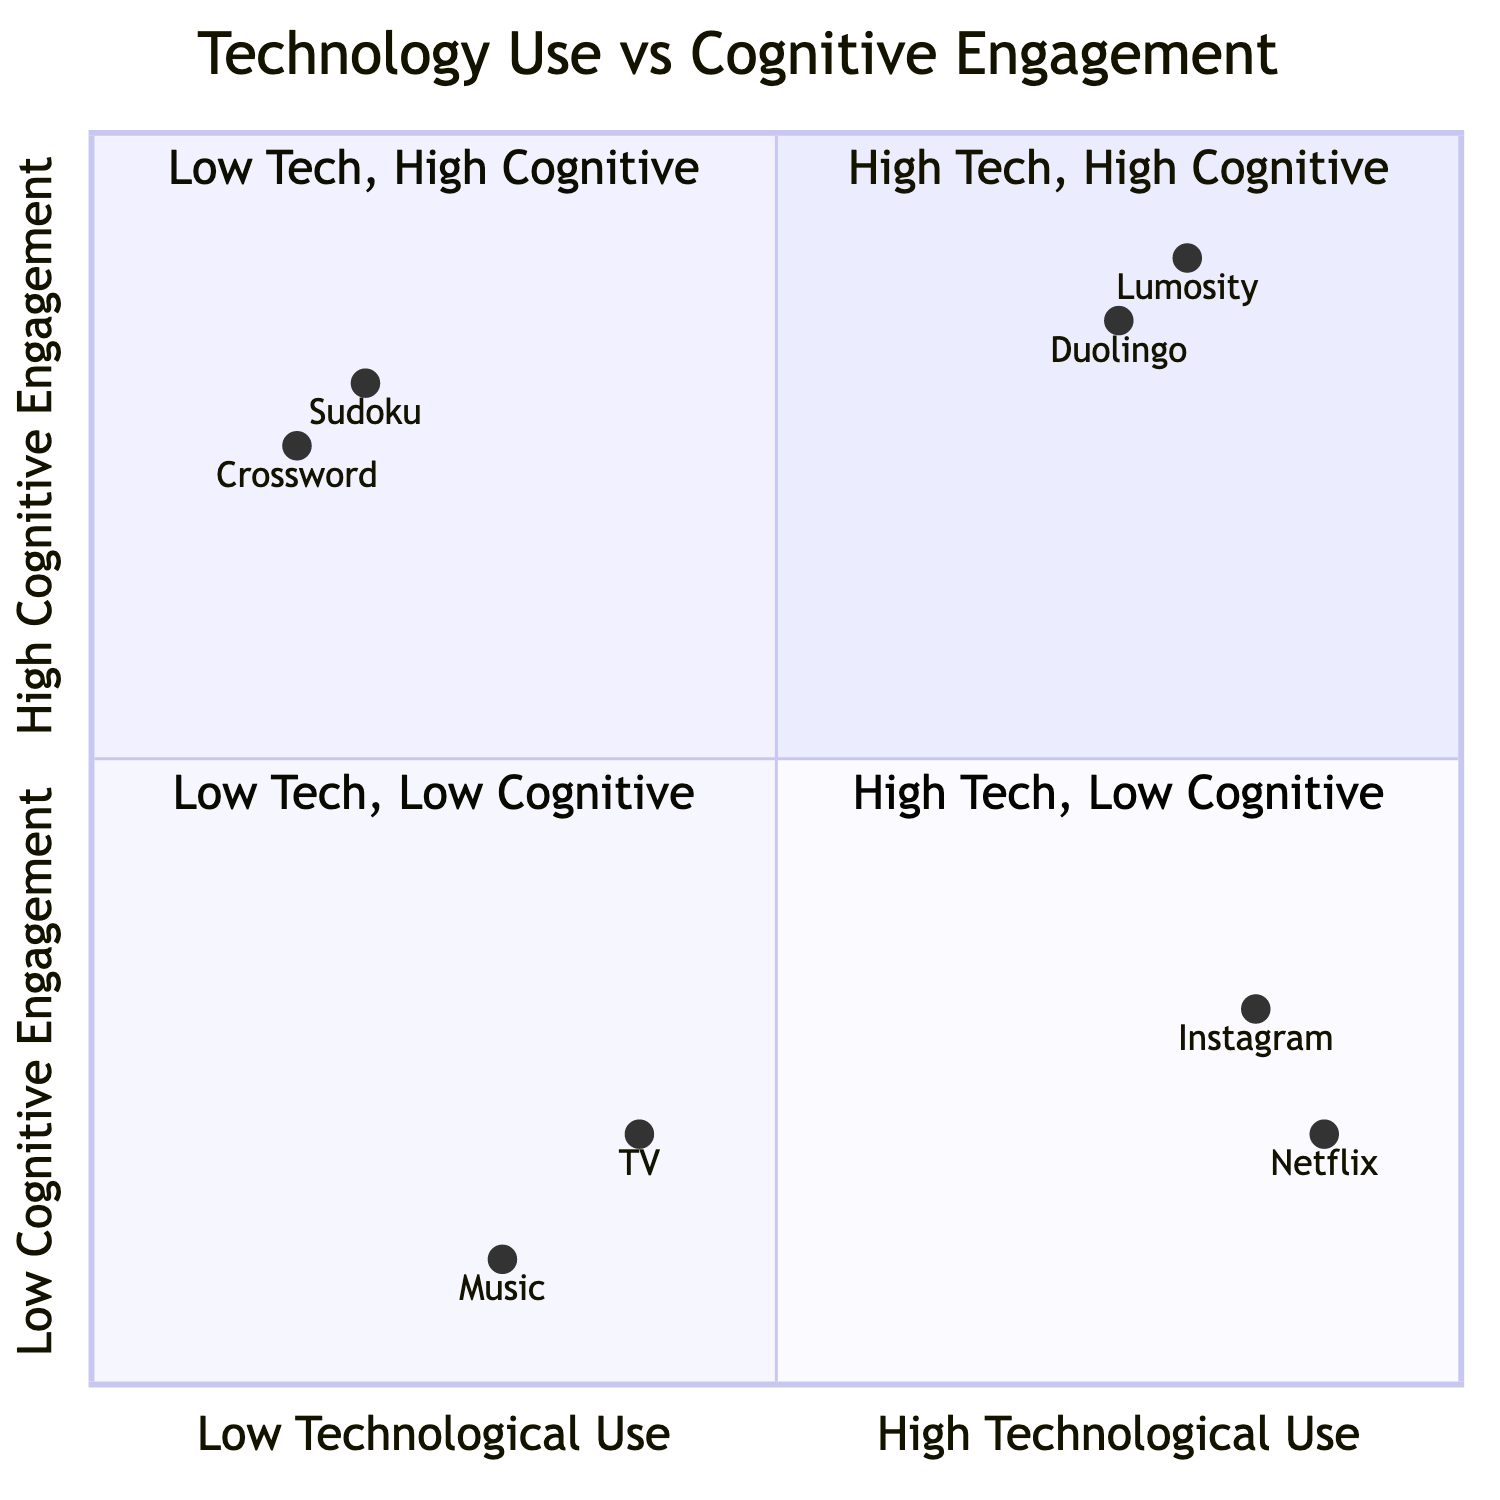What are the two apps in the "High Technological Use, High Cognitive Engagement" quadrant? The quadrant "High Technological Use, High Cognitive Engagement" contains the apps Lumosity and Duolingo. By referencing the elements listed in this quadrant, we can identify both apps directly.
Answer: Lumosity, Duolingo Which quadrant contains Sudoku? Sudoku is found in the "Low Technological Use, High Cognitive Engagement" quadrant. This can be determined by looking at the elements listed under that specific quadrant to find Sudoku.
Answer: Low Technological Use, High Cognitive Engagement How many elements are in the "Low Technological Use, Low Cognitive Engagement" quadrant? The "Low Technological Use, Low Cognitive Engagement" quadrant includes two elements: Listening to Music and Watching TV. Counting these elements shows there are two.
Answer: 2 Which app has the highest cognitive engagement among those listed? Based on the quadrant chart, Lumosity has the highest cognitive engagement score of 0.9. This is determined by comparing the cognitive engagement values of all listed apps.
Answer: Lumosity What is the technological use score of Crosswords? Crosswords has a technological use score of 0.15. This can be found by referring to the data for the element corresponding to Crosswords in the "Low Technological Use, High Cognitive Engagement" quadrant.
Answer: 0.15 Which quadrant includes Instagram? Instagram is located in the "High Technological Use, Low Cognitive Engagement" quadrant. This can be confirmed by checking where Instagram is placed within the data structure of the chart.
Answer: High Technological Use, Low Cognitive Engagement Do any elements in the "Low Technological Use, Low Cognitive Engagement" quadrant require active participation? None of the elements in the "Low Technological Use, Low Cognitive Engagement" quadrant require active participation; both Listening to Music and Watching TV are passive activities. This conclusion comes from analyzing the descriptions of the activities in that quadrant.
Answer: No What is the feature focus of Duolingo as per the diagram? The feature focus of Duolingo is on adaptive algorithms for language learning, aimed at vocabulary, grammar, and pronunciation improvement. This detail is clearly outlined in the description of the element representing Duolingo in the chart.
Answer: Adaptive algorithms for language learning 